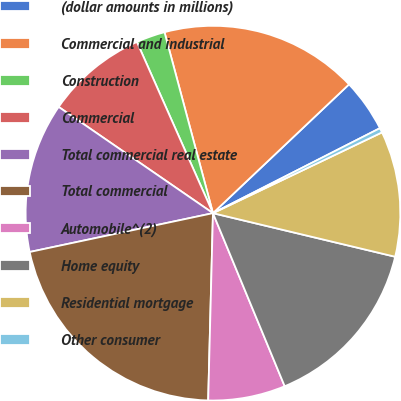Convert chart. <chart><loc_0><loc_0><loc_500><loc_500><pie_chart><fcel>(dollar amounts in millions)<fcel>Commercial and industrial<fcel>Construction<fcel>Commercial<fcel>Total commercial real estate<fcel>Total commercial<fcel>Automobile^(2)<fcel>Home equity<fcel>Residential mortgage<fcel>Other consumer<nl><fcel>4.57%<fcel>17.1%<fcel>2.49%<fcel>8.75%<fcel>12.92%<fcel>21.27%<fcel>6.66%<fcel>15.01%<fcel>10.83%<fcel>0.4%<nl></chart> 